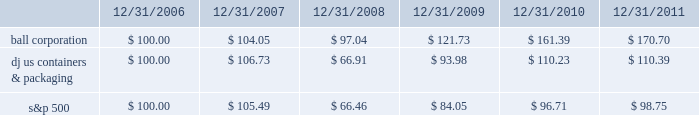Shareholder return performance the line graph below compares the annual percentage change in ball corporation fffds cumulative total shareholder return on its common stock with the cumulative total return of the dow jones containers & packaging index and the s&p composite 500 stock index for the five-year period ended december 31 , 2011 .
It assumes $ 100 was invested on december 31 , 2006 , and that all dividends were reinvested .
The dow jones containers & packaging index total return has been weighted by market capitalization .
Total return to stockholders ( assumes $ 100 investment on 12/31/06 ) total return analysis .
Copyright a9 2012 standard & poor fffds , a division of the mcgraw-hill companies inc .
All rights reserved .
( www.researchdatagroup.com/s&p.htm ) copyright a9 2012 dow jones & company .
All rights reserved. .
What was the five year return on ball corporation stock , in dollars per share? 
Computations: (170.70 - 100.00)
Answer: 70.7. 